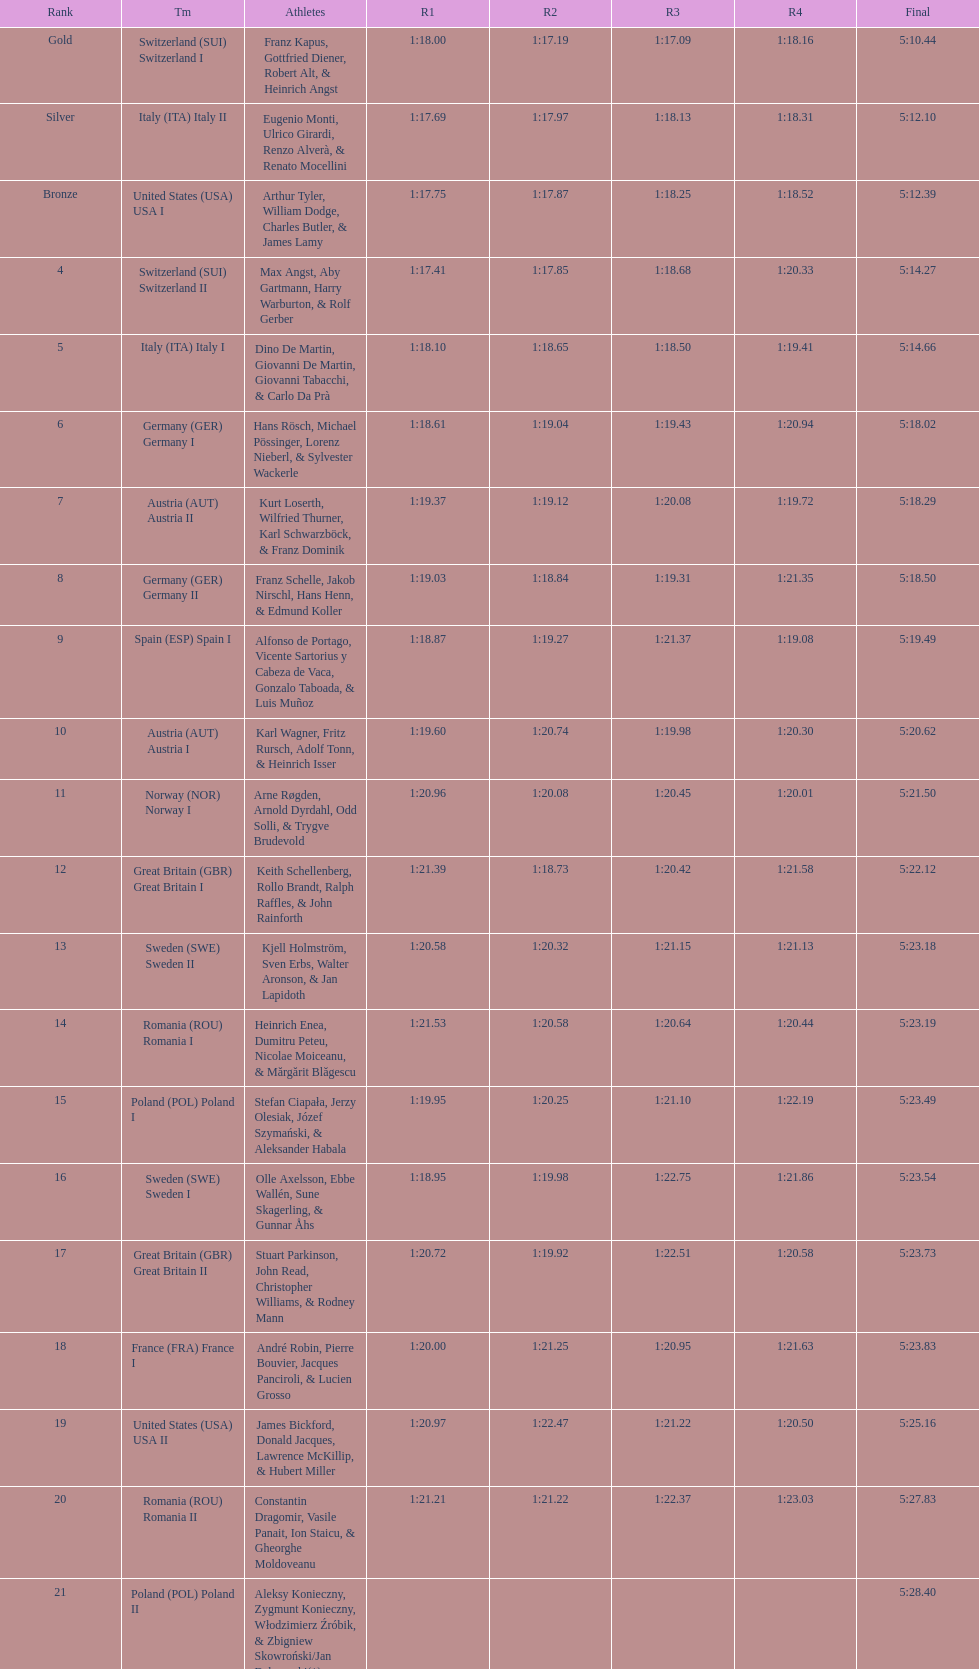What is the total amount of runs? 4. 